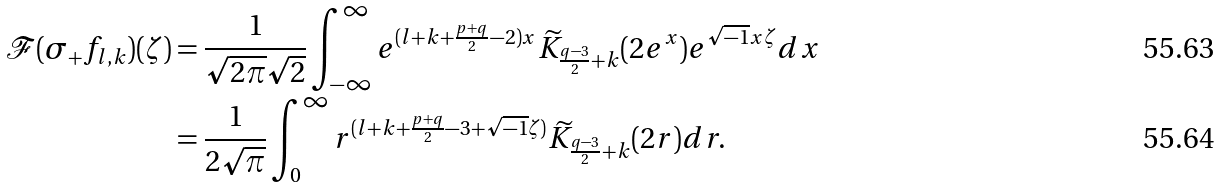<formula> <loc_0><loc_0><loc_500><loc_500>\mathcal { F } ( \sigma _ { + } f _ { l , k } ) ( \zeta ) & = \frac { 1 } { \sqrt { 2 \pi } \sqrt { 2 } } \int _ { - \infty } ^ { \infty } e ^ { ( l + k + \frac { p + q } { 2 } - 2 ) x } \widetilde { K } _ { \frac { q - 3 } { 2 } + k } ( 2 e ^ { x } ) e ^ { \sqrt { - 1 } x \zeta } d x \\ & = \frac { 1 } { 2 \sqrt { \pi } } \int _ { 0 } ^ { \infty } r ^ { ( l + k + \frac { p + q } { 2 } - 3 + \sqrt { - 1 } \zeta ) } \widetilde { K } _ { \frac { q - 3 } { 2 } + k } ( 2 r ) d r .</formula> 